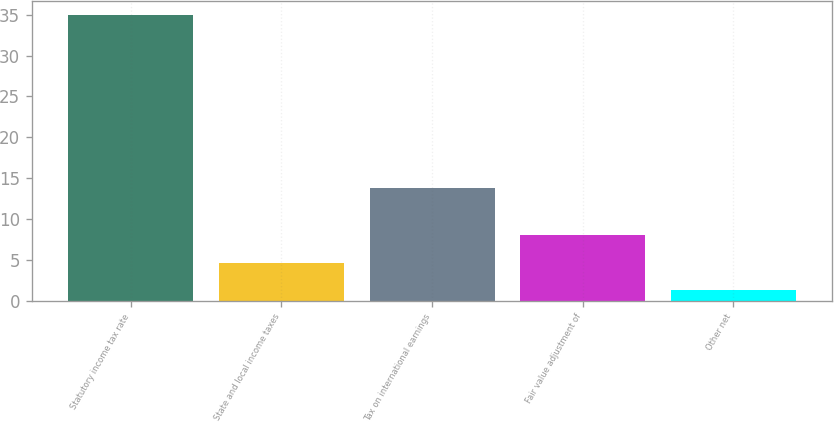Convert chart to OTSL. <chart><loc_0><loc_0><loc_500><loc_500><bar_chart><fcel>Statutory income tax rate<fcel>State and local income taxes<fcel>Tax on international earnings<fcel>Fair value adjustment of<fcel>Other net<nl><fcel>35<fcel>4.67<fcel>13.8<fcel>8.04<fcel>1.3<nl></chart> 